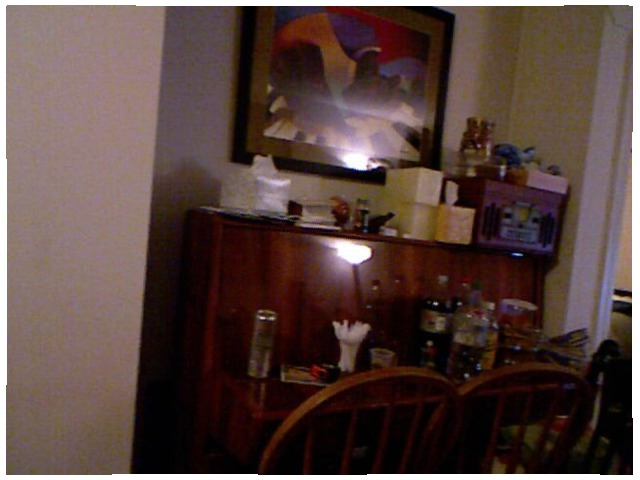<image>
Is the soda in front of the chair? Yes. The soda is positioned in front of the chair, appearing closer to the camera viewpoint. Where is the frame in relation to the wall? Is it behind the wall? No. The frame is not behind the wall. From this viewpoint, the frame appears to be positioned elsewhere in the scene. 